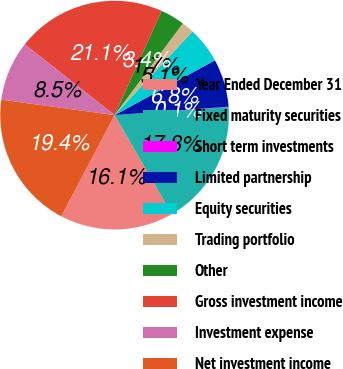<chart> <loc_0><loc_0><loc_500><loc_500><pie_chart><fcel>Year Ended December 31<fcel>Fixed maturity securities<fcel>Short term investments<fcel>Limited partnership<fcel>Equity securities<fcel>Trading portfolio<fcel>Other<fcel>Gross investment income<fcel>Investment expense<fcel>Net investment income<nl><fcel>16.07%<fcel>17.76%<fcel>0.06%<fcel>6.79%<fcel>5.11%<fcel>1.75%<fcel>3.43%<fcel>21.12%<fcel>8.47%<fcel>19.44%<nl></chart> 